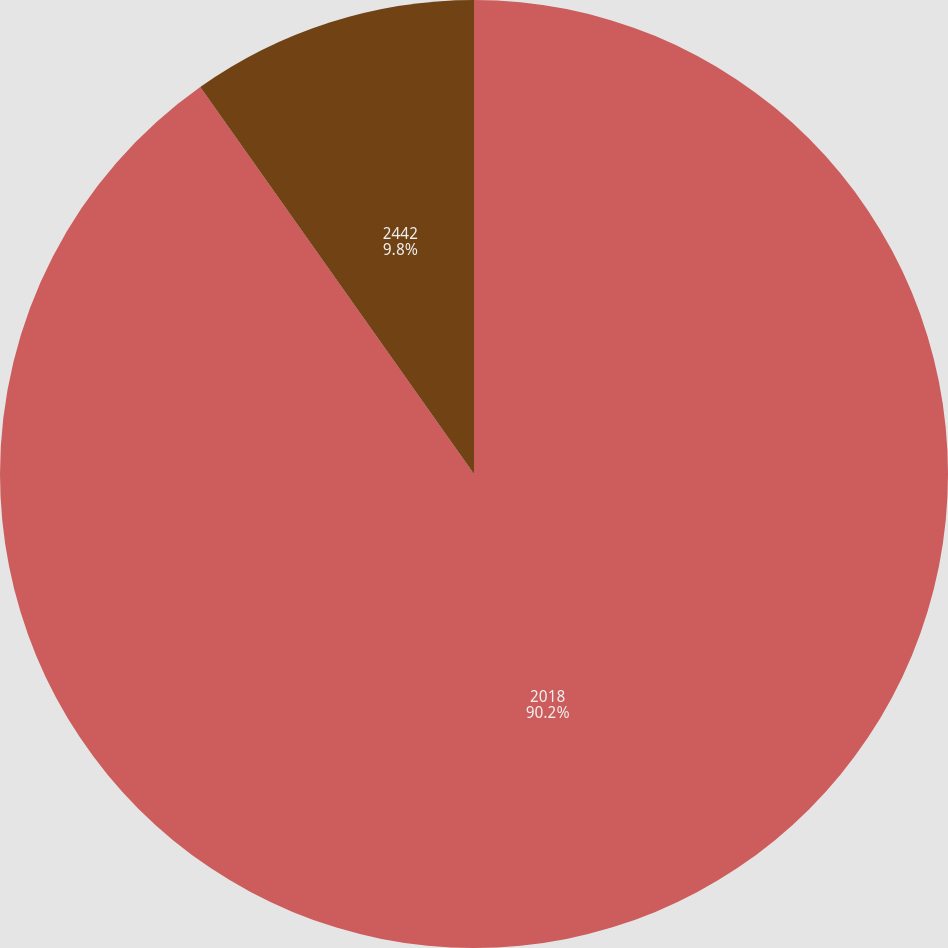<chart> <loc_0><loc_0><loc_500><loc_500><pie_chart><fcel>2018<fcel>2442<nl><fcel>90.2%<fcel>9.8%<nl></chart> 